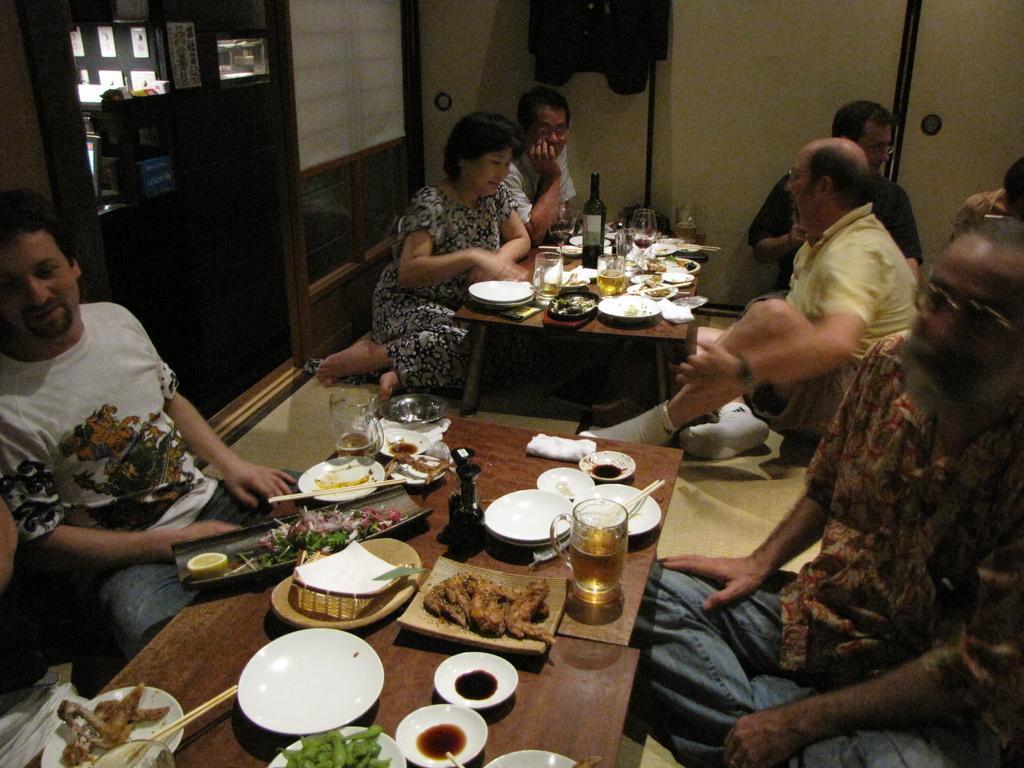Can you describe this image briefly? In this image there are group of people sitting at the floor and in table there are plates, glasses, food, chopsticks, tissues, tray, bottles and in back ground there is door, window. 